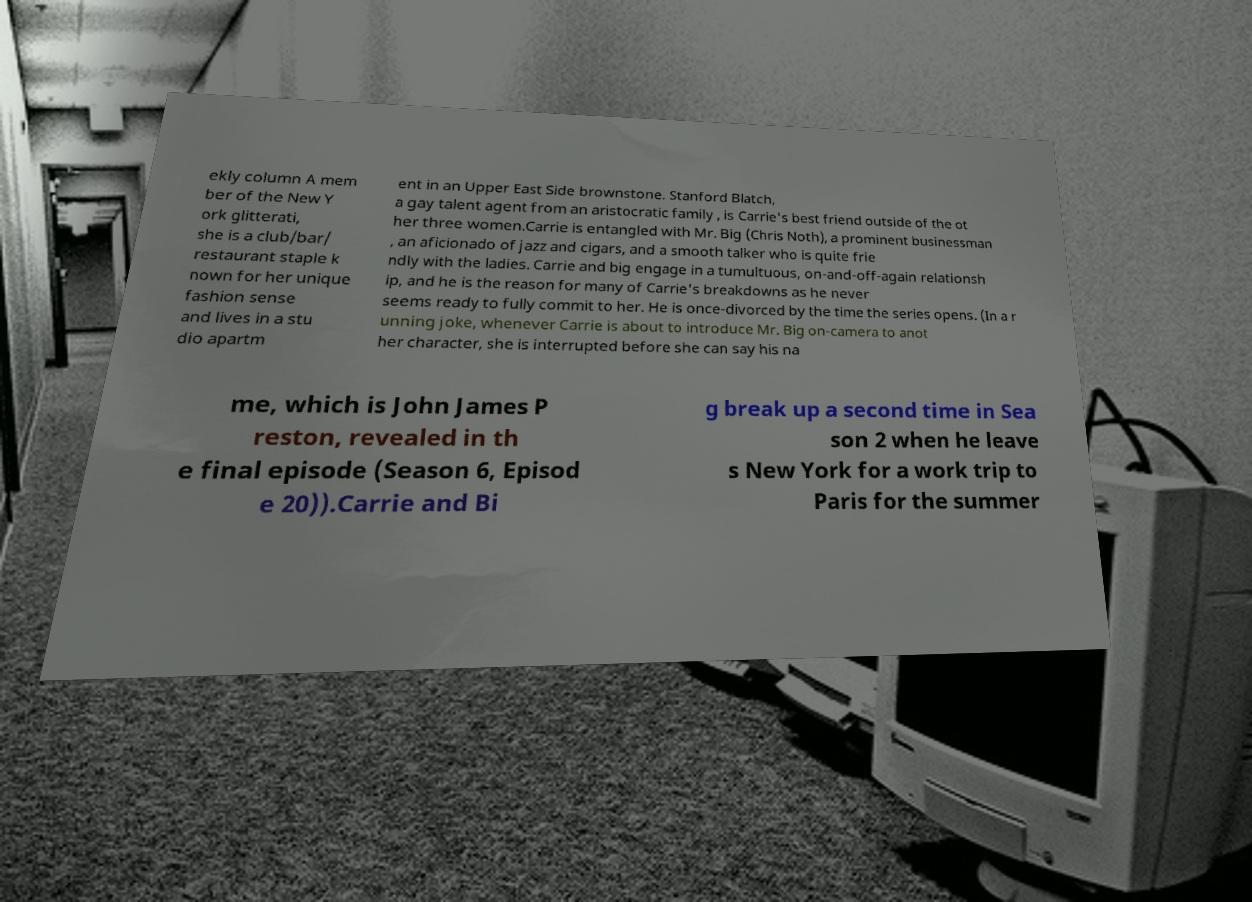What messages or text are displayed in this image? I need them in a readable, typed format. ekly column A mem ber of the New Y ork glitterati, she is a club/bar/ restaurant staple k nown for her unique fashion sense and lives in a stu dio apartm ent in an Upper East Side brownstone. Stanford Blatch, a gay talent agent from an aristocratic family , is Carrie's best friend outside of the ot her three women.Carrie is entangled with Mr. Big (Chris Noth), a prominent businessman , an aficionado of jazz and cigars, and a smooth talker who is quite frie ndly with the ladies. Carrie and big engage in a tumultuous, on-and-off-again relationsh ip, and he is the reason for many of Carrie's breakdowns as he never seems ready to fully commit to her. He is once-divorced by the time the series opens. (In a r unning joke, whenever Carrie is about to introduce Mr. Big on-camera to anot her character, she is interrupted before she can say his na me, which is John James P reston, revealed in th e final episode (Season 6, Episod e 20)).Carrie and Bi g break up a second time in Sea son 2 when he leave s New York for a work trip to Paris for the summer 